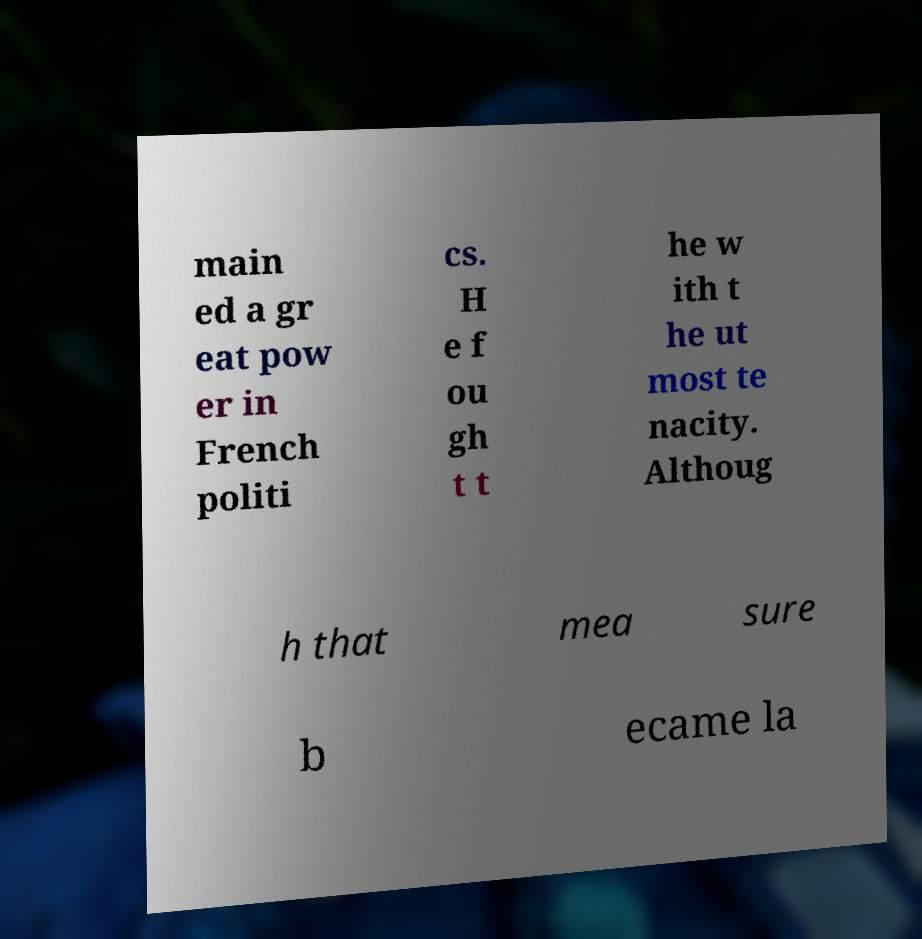There's text embedded in this image that I need extracted. Can you transcribe it verbatim? main ed a gr eat pow er in French politi cs. H e f ou gh t t he w ith t he ut most te nacity. Althoug h that mea sure b ecame la 